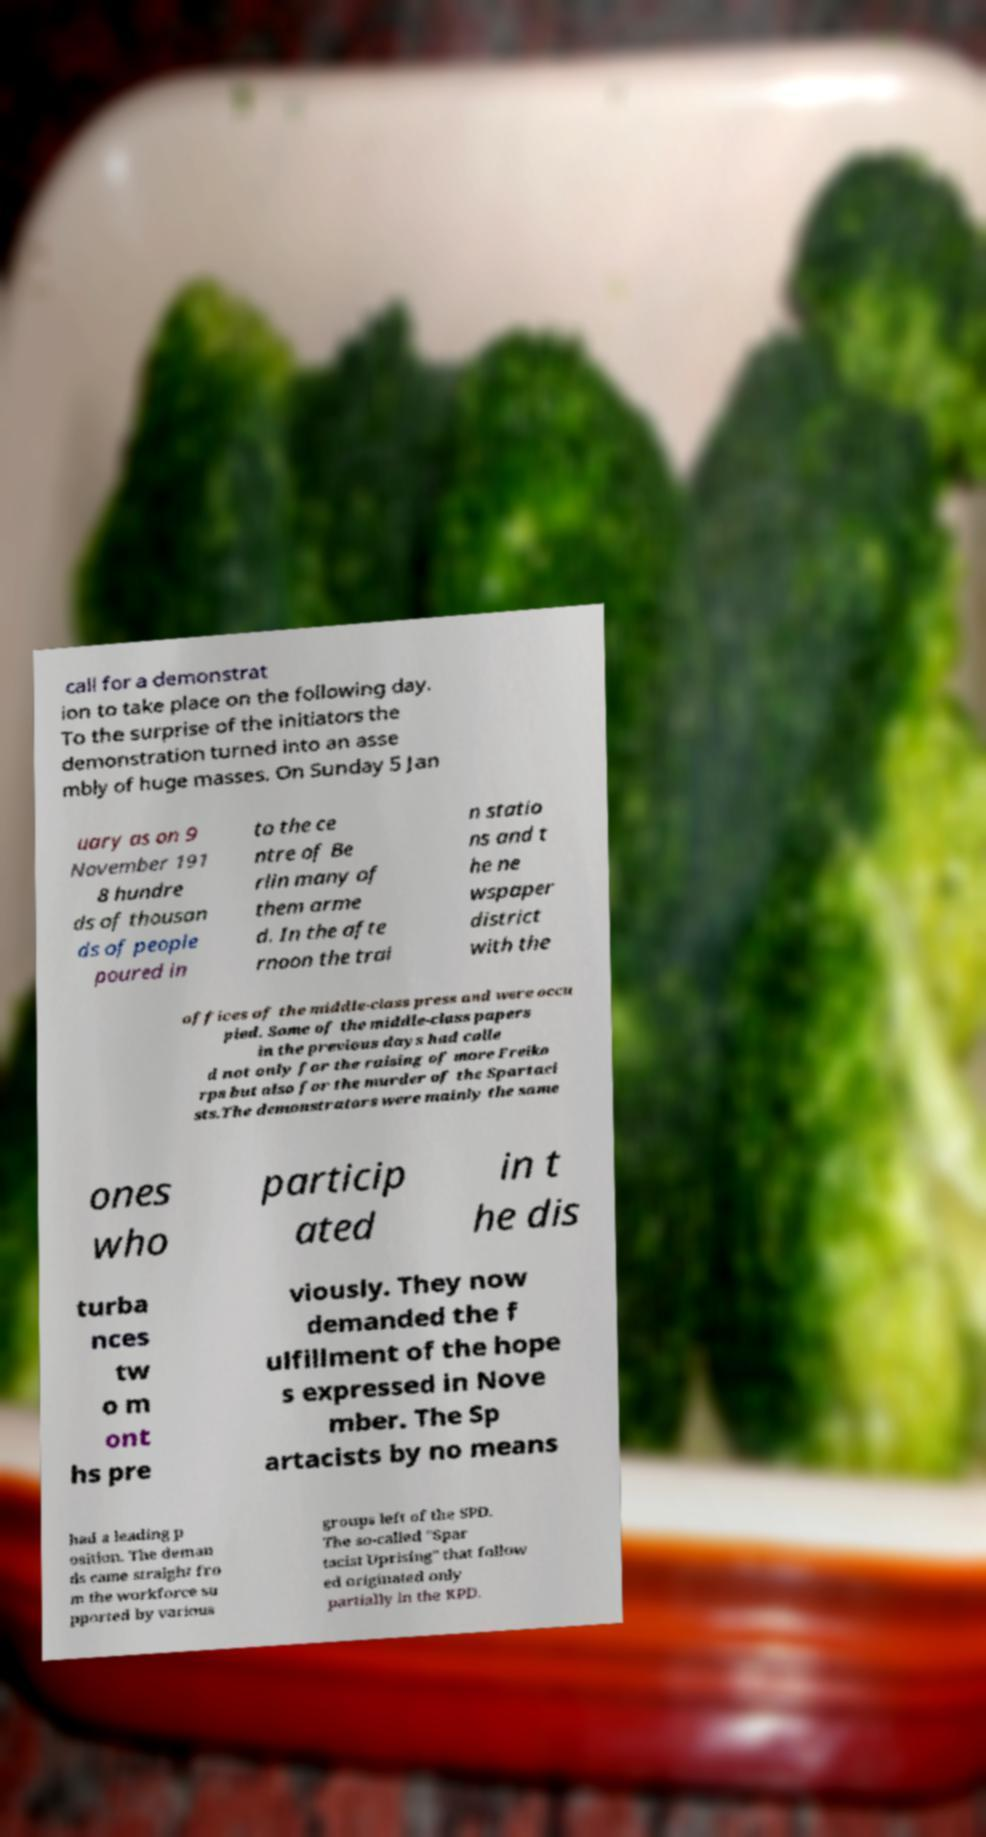Please read and relay the text visible in this image. What does it say? call for a demonstrat ion to take place on the following day. To the surprise of the initiators the demonstration turned into an asse mbly of huge masses. On Sunday 5 Jan uary as on 9 November 191 8 hundre ds of thousan ds of people poured in to the ce ntre of Be rlin many of them arme d. In the afte rnoon the trai n statio ns and t he ne wspaper district with the offices of the middle-class press and were occu pied. Some of the middle-class papers in the previous days had calle d not only for the raising of more Freiko rps but also for the murder of the Spartaci sts.The demonstrators were mainly the same ones who particip ated in t he dis turba nces tw o m ont hs pre viously. They now demanded the f ulfillment of the hope s expressed in Nove mber. The Sp artacists by no means had a leading p osition. The deman ds came straight fro m the workforce su pported by various groups left of the SPD. The so-called "Spar tacist Uprising" that follow ed originated only partially in the KPD. 